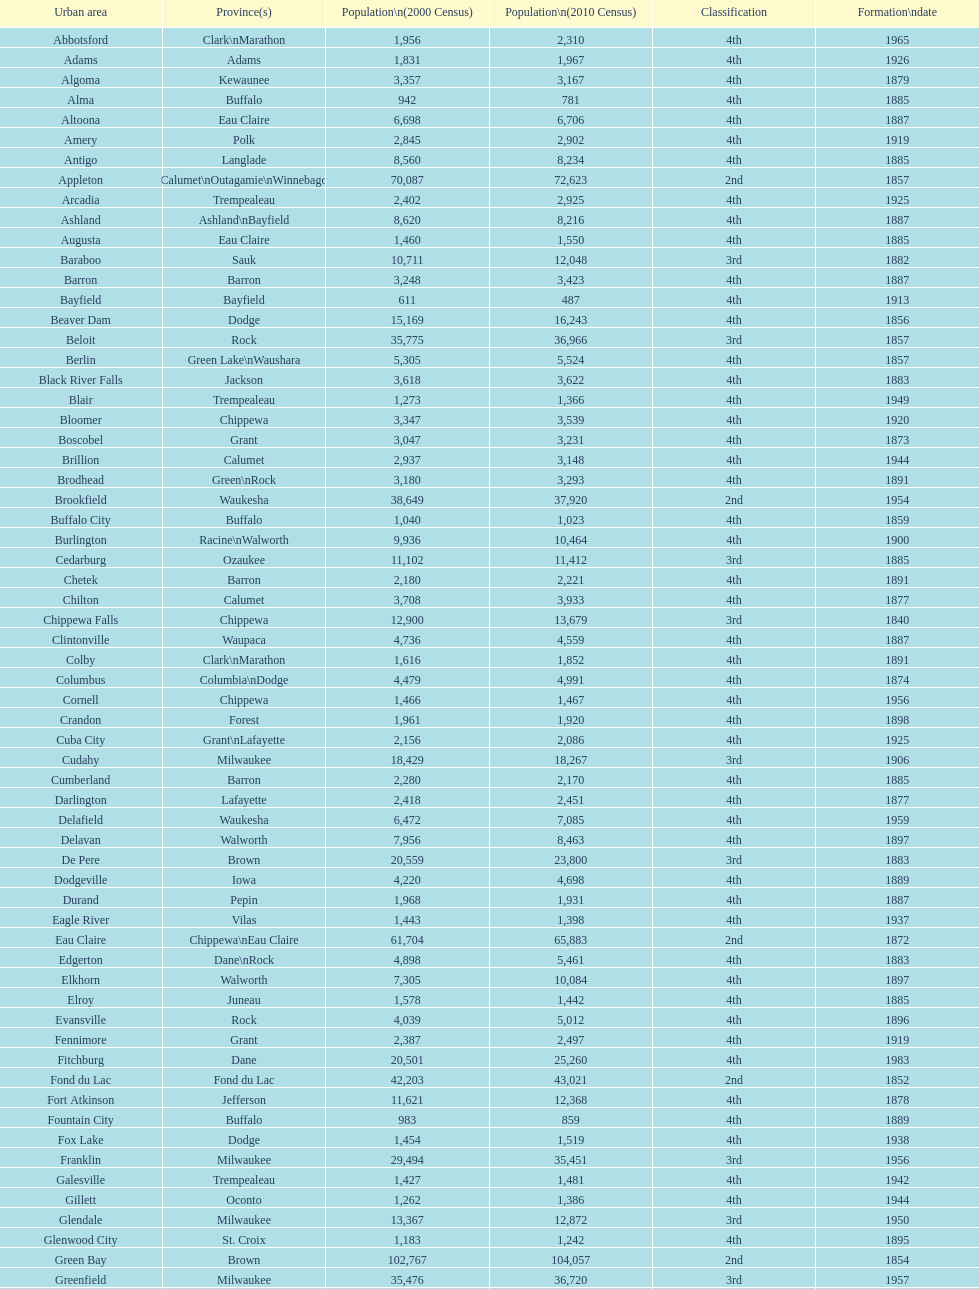How many cities have 1926 as their incorporation date? 2. 